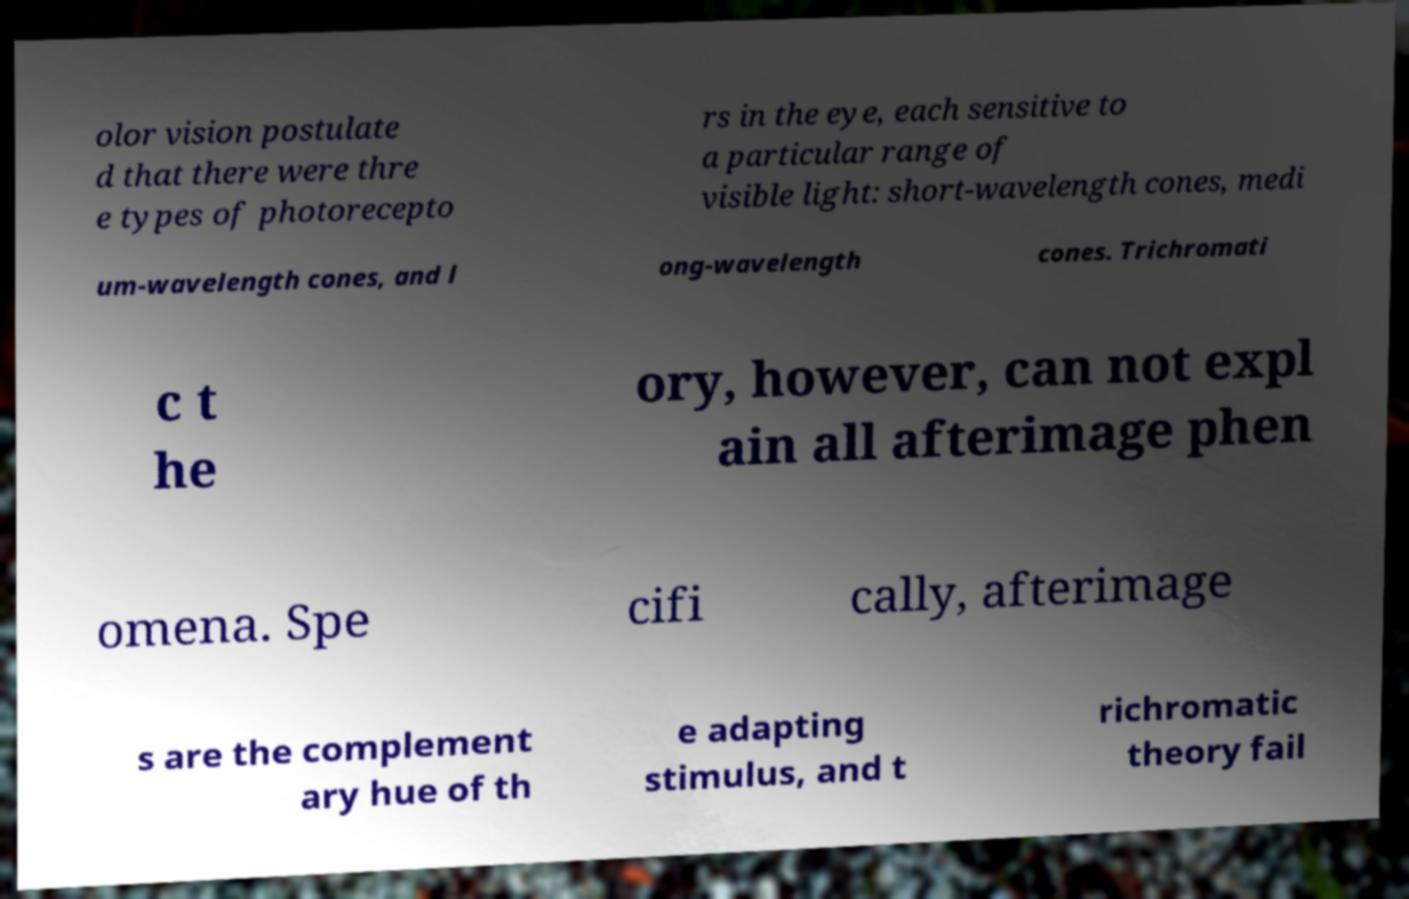There's text embedded in this image that I need extracted. Can you transcribe it verbatim? olor vision postulate d that there were thre e types of photorecepto rs in the eye, each sensitive to a particular range of visible light: short-wavelength cones, medi um-wavelength cones, and l ong-wavelength cones. Trichromati c t he ory, however, can not expl ain all afterimage phen omena. Spe cifi cally, afterimage s are the complement ary hue of th e adapting stimulus, and t richromatic theory fail 